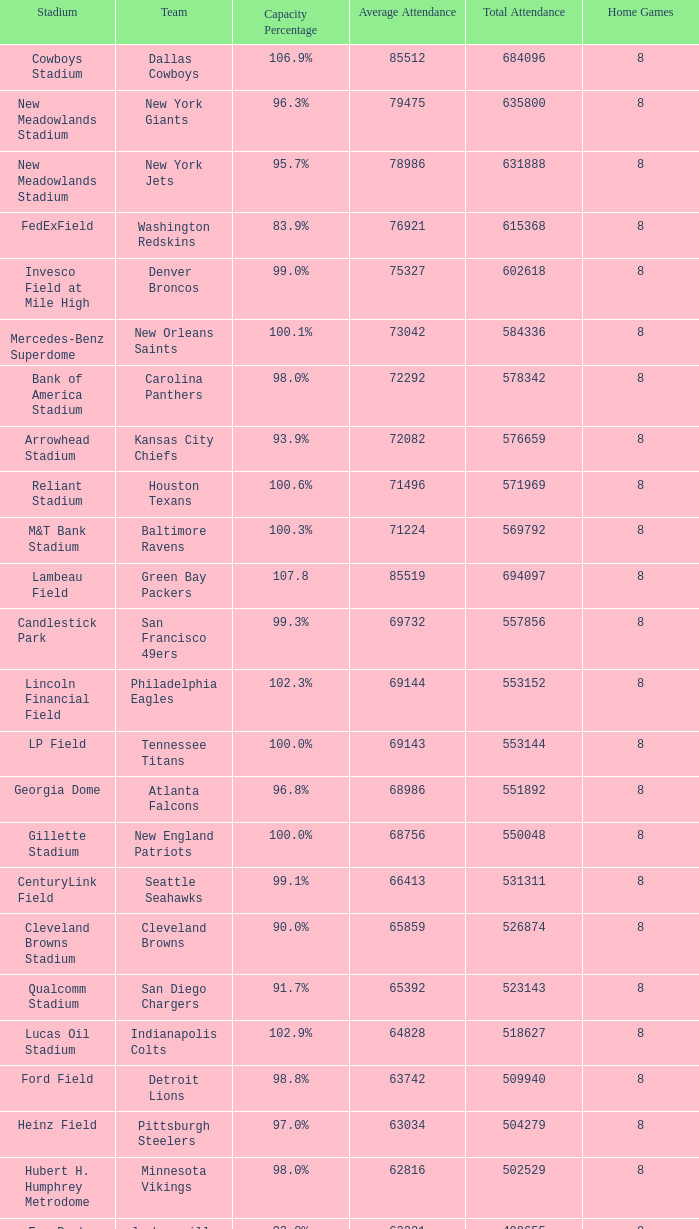What is the name of the team when the stadium is listed as Edward Jones Dome? St. Louis Rams. 